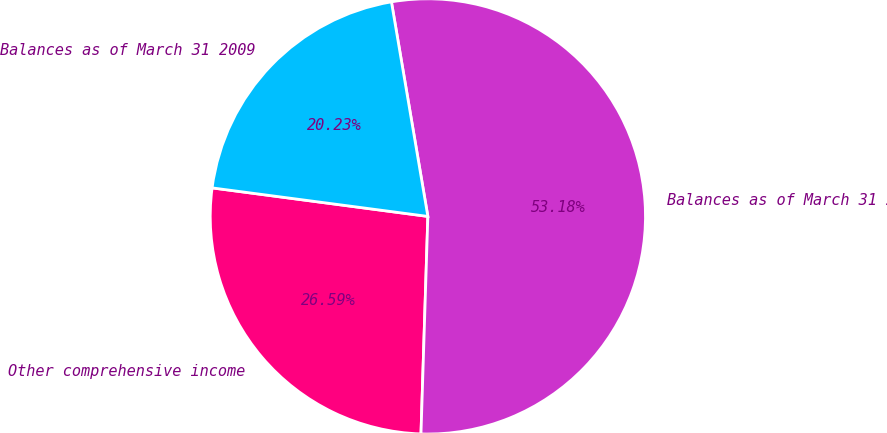Convert chart to OTSL. <chart><loc_0><loc_0><loc_500><loc_500><pie_chart><fcel>Other comprehensive income<fcel>Balances as of March 31 2008<fcel>Balances as of March 31 2009<nl><fcel>26.59%<fcel>53.18%<fcel>20.23%<nl></chart> 